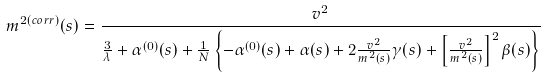Convert formula to latex. <formula><loc_0><loc_0><loc_500><loc_500>m ^ { 2 ( c o r r ) } ( s ) = \frac { v ^ { 2 } } { \frac { 3 } { \lambda } + \alpha ^ { ( 0 ) } ( s ) + \frac { 1 } { N } \left \{ - \alpha ^ { ( 0 ) } ( s ) + \alpha ( s ) + 2 \frac { v ^ { 2 } } { m ^ { 2 } ( s ) } \gamma ( s ) + \left [ \frac { v ^ { 2 } } { m ^ { 2 } ( s ) } \right ] ^ { 2 } \beta ( s ) \right \} }</formula> 